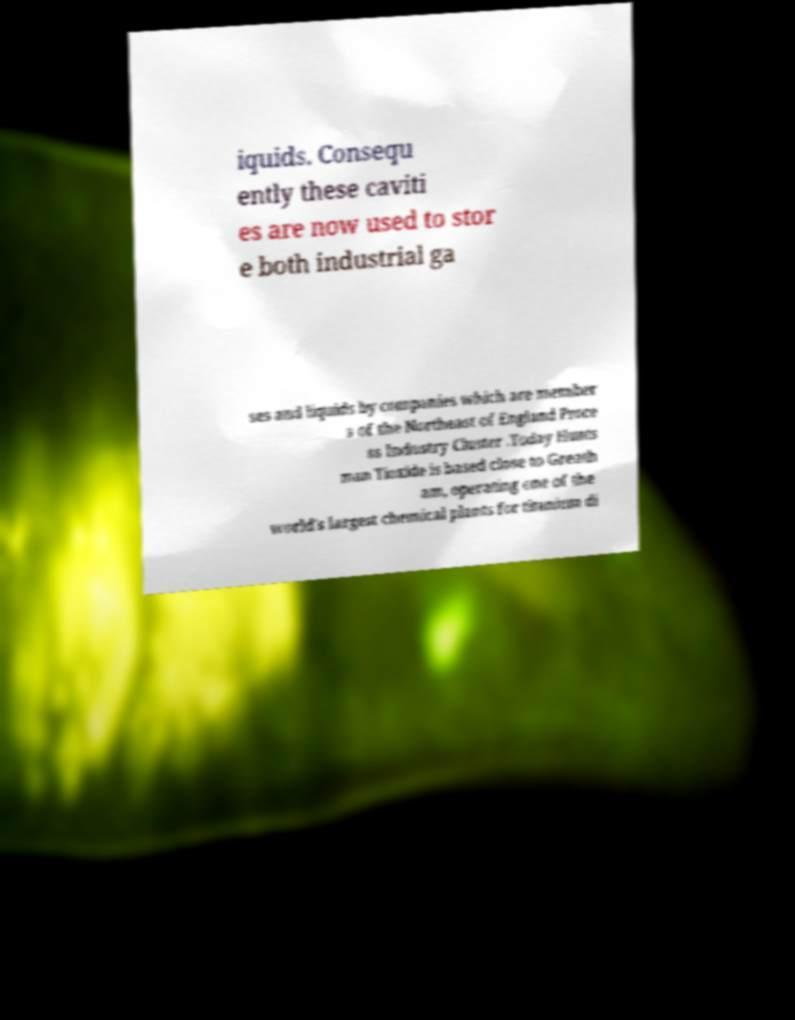Can you accurately transcribe the text from the provided image for me? iquids. Consequ ently these caviti es are now used to stor e both industrial ga ses and liquids by companies which are member s of the Northeast of England Proce ss Industry Cluster .Today Hunts man Tioxide is based close to Greath am, operating one of the world's largest chemical plants for titanium di 